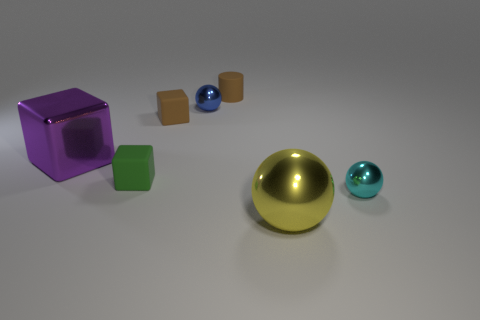Do the brown thing that is in front of the blue object and the brown cylinder have the same size?
Your answer should be compact. Yes. How many large things are purple shiny blocks or brown blocks?
Provide a short and direct response. 1. Is there a tiny sphere that has the same color as the tiny cylinder?
Your answer should be compact. No. There is a green rubber thing that is the same size as the blue object; what is its shape?
Your response must be concise. Cube. There is a big shiny cube to the left of the small blue thing; is it the same color as the large shiny sphere?
Make the answer very short. No. What number of things are small shiny objects to the left of the yellow sphere or cyan shiny balls?
Offer a terse response. 2. Are there more blue things in front of the big metal sphere than green things that are right of the rubber cylinder?
Provide a succinct answer. No. Is the material of the purple thing the same as the cylinder?
Provide a succinct answer. No. There is a metal object that is both right of the big purple block and on the left side of the yellow shiny object; what shape is it?
Make the answer very short. Sphere. The big purple thing that is made of the same material as the big yellow object is what shape?
Offer a terse response. Cube. 